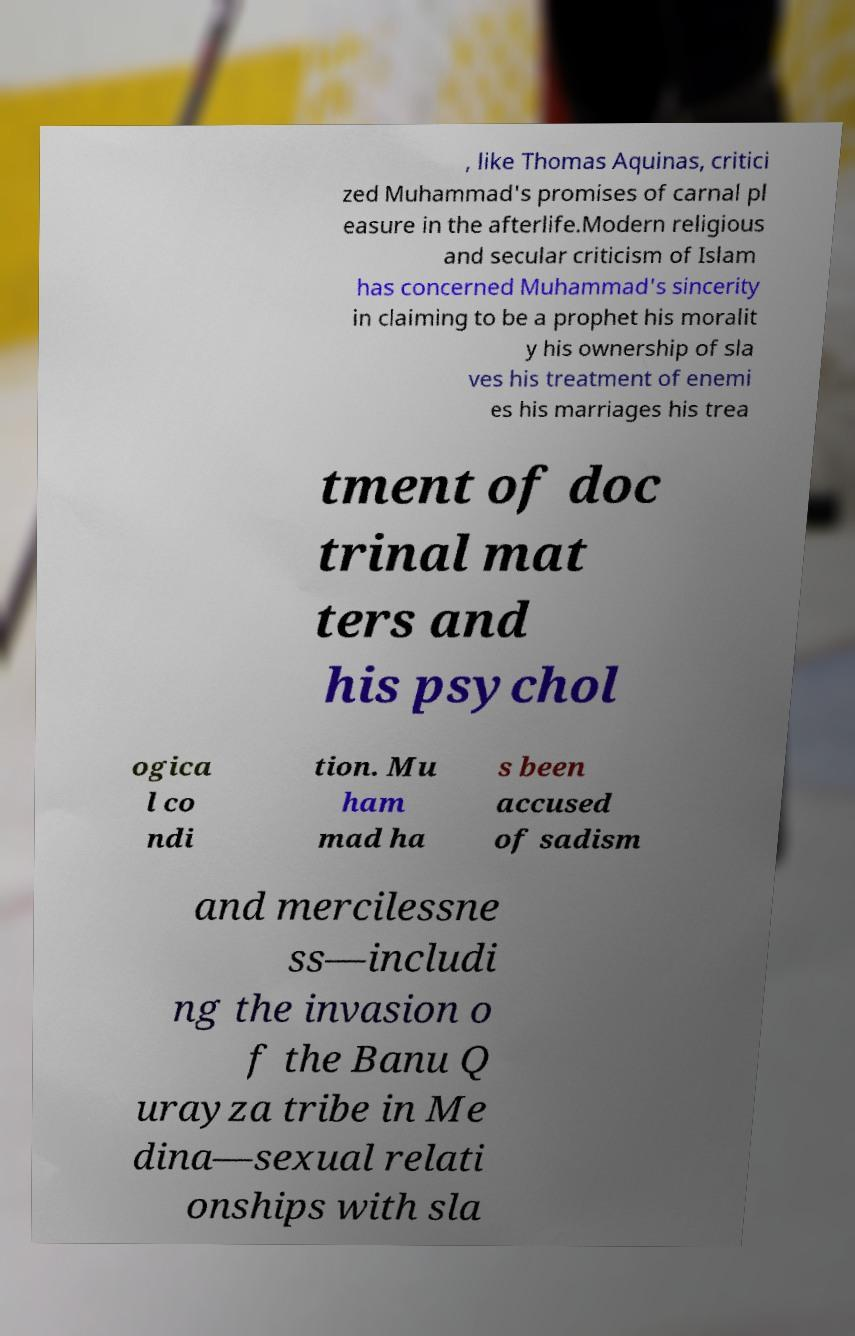Please read and relay the text visible in this image. What does it say? , like Thomas Aquinas, critici zed Muhammad's promises of carnal pl easure in the afterlife.Modern religious and secular criticism of Islam has concerned Muhammad's sincerity in claiming to be a prophet his moralit y his ownership of sla ves his treatment of enemi es his marriages his trea tment of doc trinal mat ters and his psychol ogica l co ndi tion. Mu ham mad ha s been accused of sadism and mercilessne ss—includi ng the invasion o f the Banu Q urayza tribe in Me dina—sexual relati onships with sla 